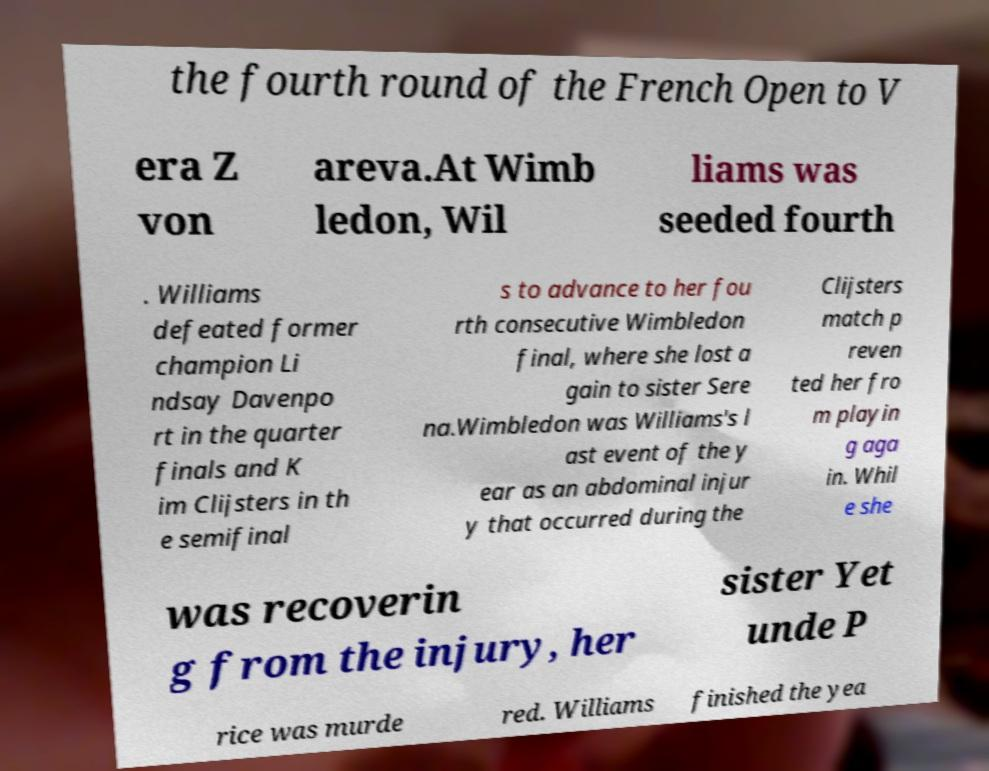Please read and relay the text visible in this image. What does it say? the fourth round of the French Open to V era Z von areva.At Wimb ledon, Wil liams was seeded fourth . Williams defeated former champion Li ndsay Davenpo rt in the quarter finals and K im Clijsters in th e semifinal s to advance to her fou rth consecutive Wimbledon final, where she lost a gain to sister Sere na.Wimbledon was Williams's l ast event of the y ear as an abdominal injur y that occurred during the Clijsters match p reven ted her fro m playin g aga in. Whil e she was recoverin g from the injury, her sister Yet unde P rice was murde red. Williams finished the yea 